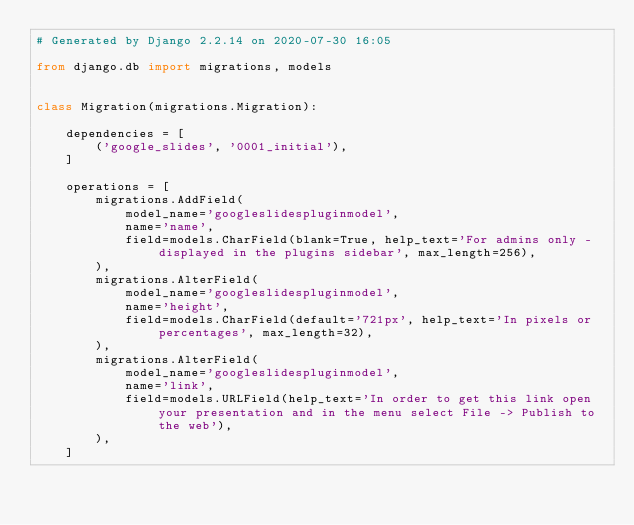Convert code to text. <code><loc_0><loc_0><loc_500><loc_500><_Python_># Generated by Django 2.2.14 on 2020-07-30 16:05

from django.db import migrations, models


class Migration(migrations.Migration):

    dependencies = [
        ('google_slides', '0001_initial'),
    ]

    operations = [
        migrations.AddField(
            model_name='googleslidespluginmodel',
            name='name',
            field=models.CharField(blank=True, help_text='For admins only - displayed in the plugins sidebar', max_length=256),
        ),
        migrations.AlterField(
            model_name='googleslidespluginmodel',
            name='height',
            field=models.CharField(default='721px', help_text='In pixels or percentages', max_length=32),
        ),
        migrations.AlterField(
            model_name='googleslidespluginmodel',
            name='link',
            field=models.URLField(help_text='In order to get this link open your presentation and in the menu select File -> Publish to the web'),
        ),
    ]
</code> 